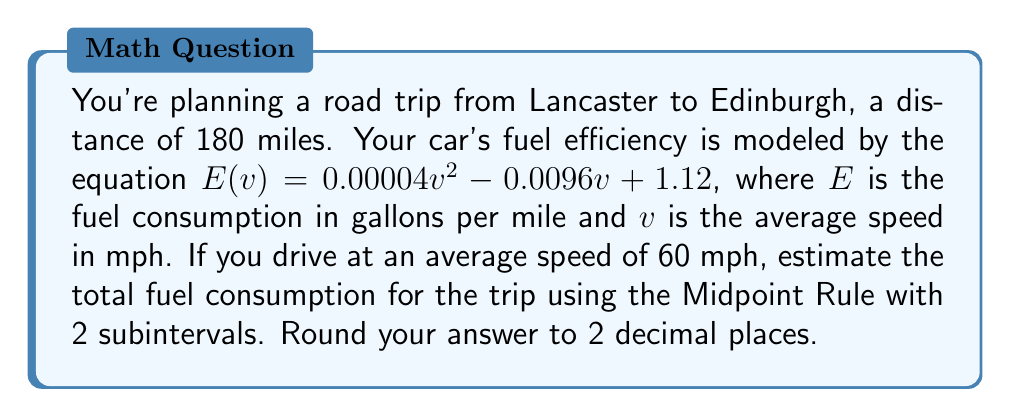Could you help me with this problem? 1) The Midpoint Rule for numerical integration is given by:
   $$\int_a^b f(x) dx \approx \frac{b-a}{n} \sum_{i=1}^n f(x_i)$$
   where $x_i$ is the midpoint of the $i$-th subinterval.

2) In this case, $a=0$, $b=180$, $n=2$, and $f(x) = E(60) = 0.00004(60)^2 - 0.0096(60) + 1.12$

3) Calculate $E(60)$:
   $E(60) = 0.00004(3600) - 0.0096(60) + 1.12$
   $E(60) = 0.144 - 0.576 + 1.12 = 0.688$ gallons per mile

4) The width of each subinterval is $(b-a)/n = 180/2 = 90$ miles

5) The midpoints of the subintervals are:
   $x_1 = 45$ miles
   $x_2 = 135$ miles

6) Apply the Midpoint Rule:
   $$\text{Fuel Consumption} \approx 90 [f(45) + f(135)]$$
   $$= 90 [0.688 + 0.688]$$
   $$= 90 (1.376)$$
   $$= 123.84$$

7) Round to 2 decimal places: 123.84 gallons
Answer: 123.84 gallons 